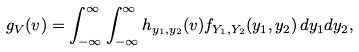Convert formula to latex. <formula><loc_0><loc_0><loc_500><loc_500>g _ { V } ( v ) = \int _ { - \infty } ^ { \infty } \int _ { - \infty } ^ { \infty } h _ { y _ { 1 } , y _ { 2 } } ( v ) f _ { Y _ { 1 } , Y _ { 2 } } ( y _ { 1 } , y _ { 2 } ) \, d y _ { 1 } d y _ { 2 } ,</formula> 